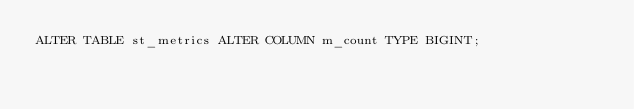Convert code to text. <code><loc_0><loc_0><loc_500><loc_500><_SQL_>ALTER TABLE st_metrics ALTER COLUMN m_count TYPE BIGINT;</code> 